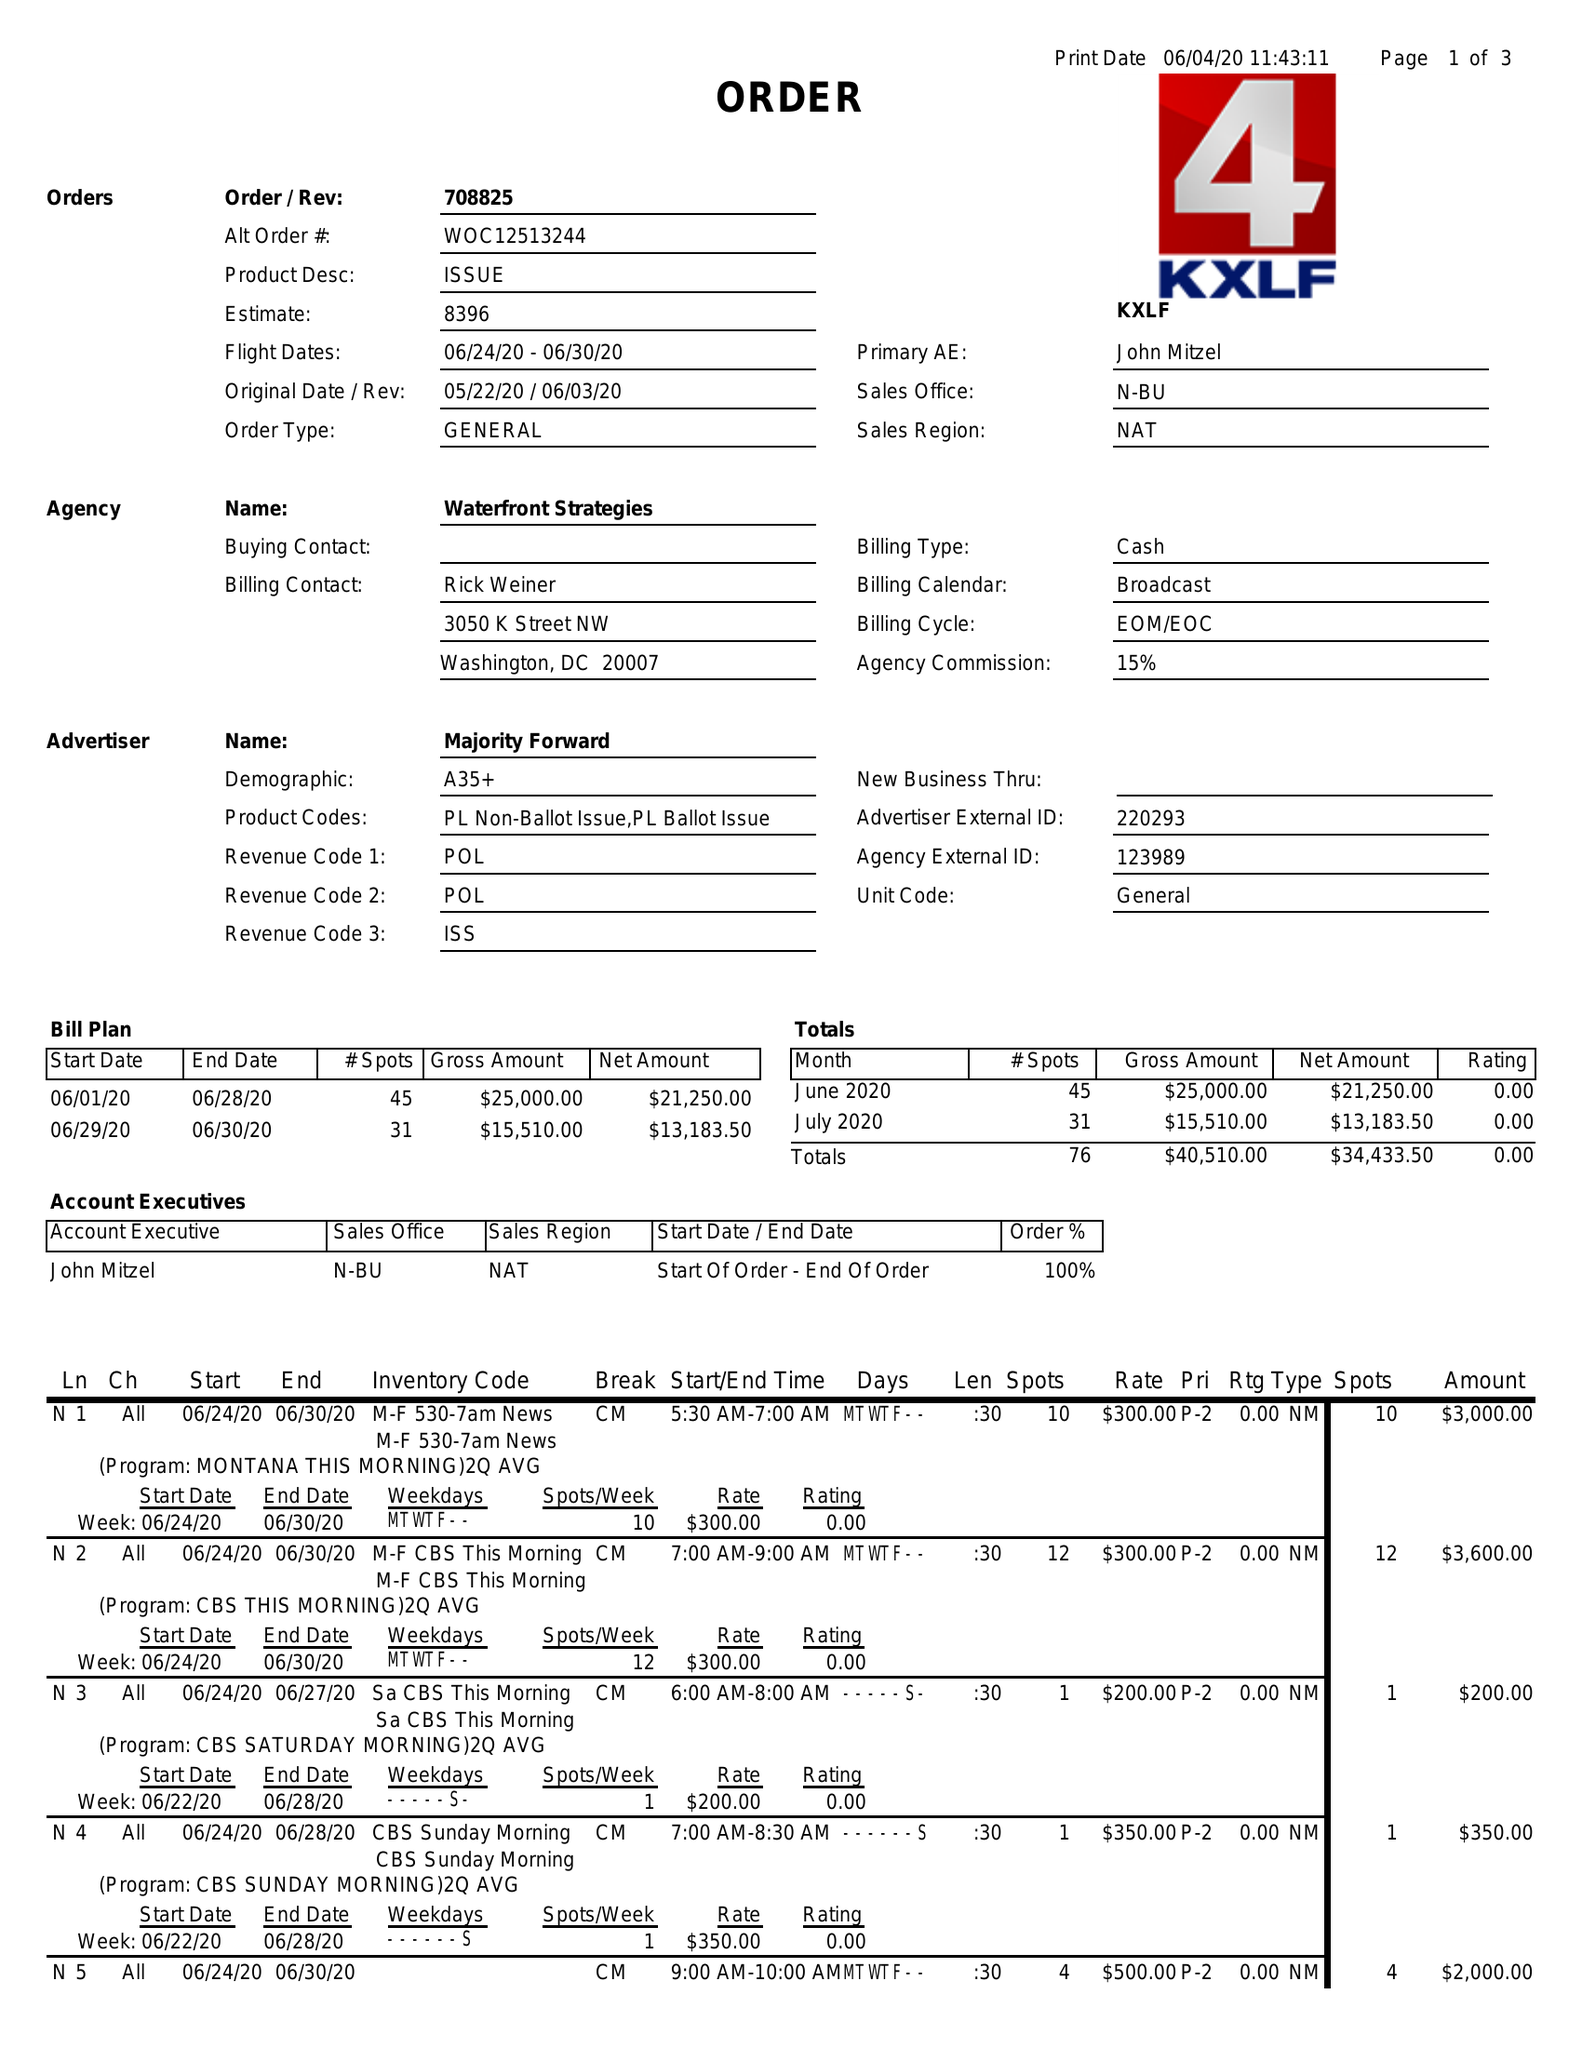What is the value for the contract_num?
Answer the question using a single word or phrase. 708825 